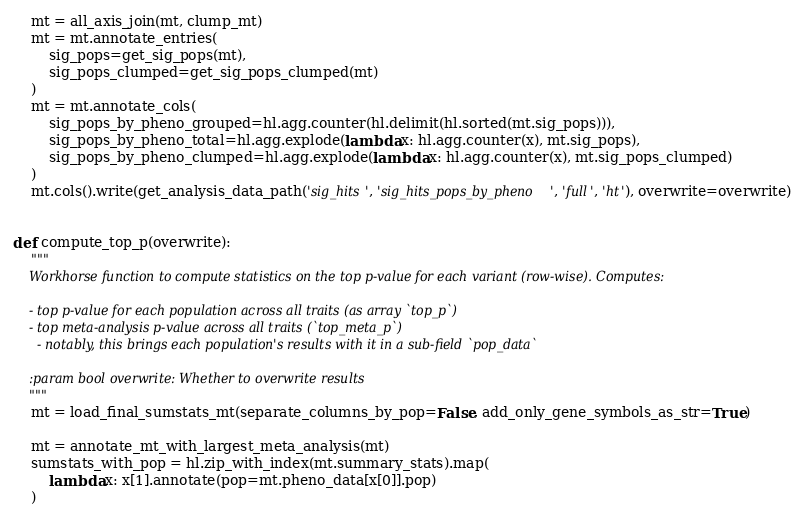<code> <loc_0><loc_0><loc_500><loc_500><_Python_>    mt = all_axis_join(mt, clump_mt)
    mt = mt.annotate_entries(
        sig_pops=get_sig_pops(mt),
        sig_pops_clumped=get_sig_pops_clumped(mt)
    )
    mt = mt.annotate_cols(
        sig_pops_by_pheno_grouped=hl.agg.counter(hl.delimit(hl.sorted(mt.sig_pops))),
        sig_pops_by_pheno_total=hl.agg.explode(lambda x: hl.agg.counter(x), mt.sig_pops),
        sig_pops_by_pheno_clumped=hl.agg.explode(lambda x: hl.agg.counter(x), mt.sig_pops_clumped)
    )
    mt.cols().write(get_analysis_data_path('sig_hits', 'sig_hits_pops_by_pheno', 'full', 'ht'), overwrite=overwrite)


def compute_top_p(overwrite):
    """
    Workhorse function to compute statistics on the top p-value for each variant (row-wise). Computes:

    - top p-value for each population across all traits (as array `top_p`)
    - top meta-analysis p-value across all traits (`top_meta_p`)
      - notably, this brings each population's results with it in a sub-field `pop_data`

    :param bool overwrite: Whether to overwrite results
    """
    mt = load_final_sumstats_mt(separate_columns_by_pop=False, add_only_gene_symbols_as_str=True)

    mt = annotate_mt_with_largest_meta_analysis(mt)
    sumstats_with_pop = hl.zip_with_index(mt.summary_stats).map(
        lambda x: x[1].annotate(pop=mt.pheno_data[x[0]].pop)
    )</code> 